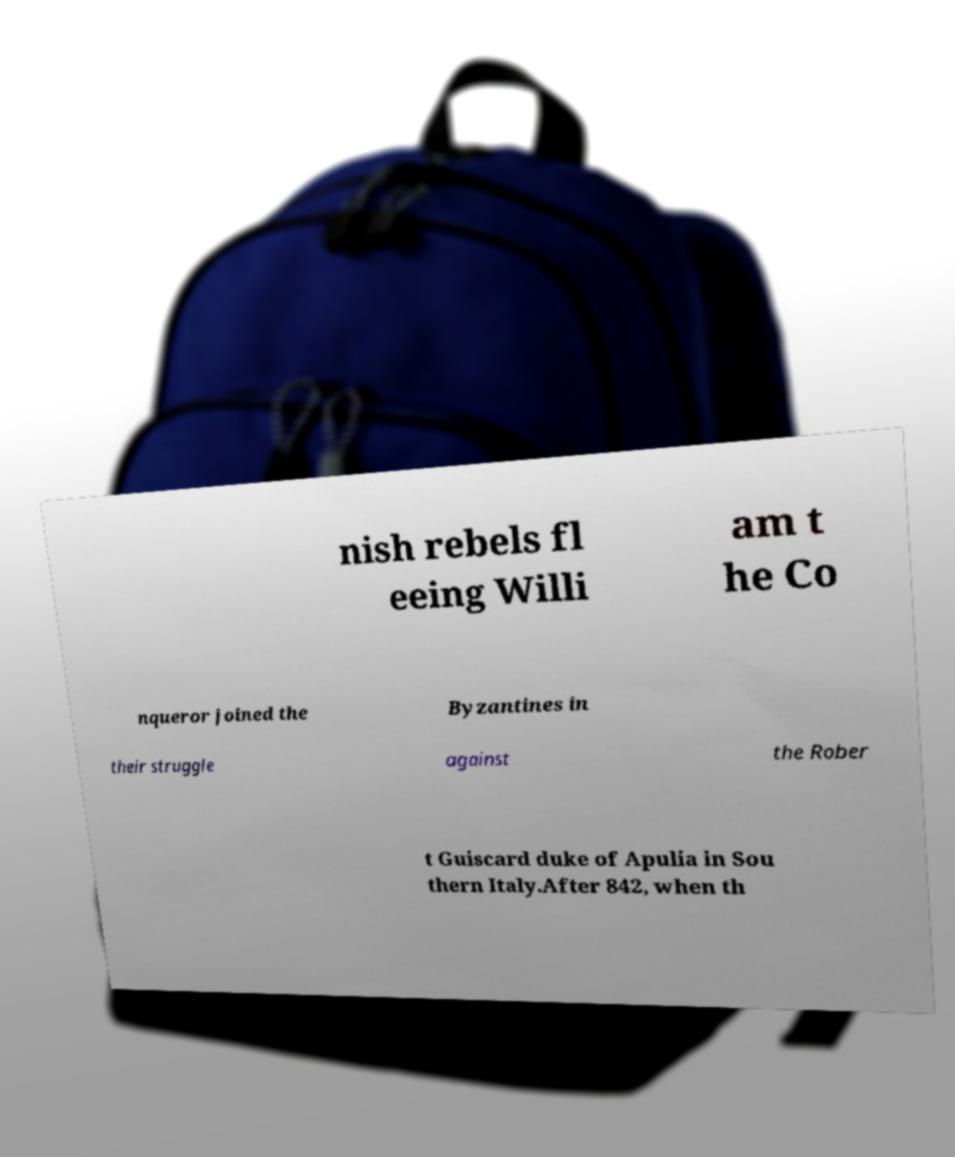What messages or text are displayed in this image? I need them in a readable, typed format. nish rebels fl eeing Willi am t he Co nqueror joined the Byzantines in their struggle against the Rober t Guiscard duke of Apulia in Sou thern Italy.After 842, when th 